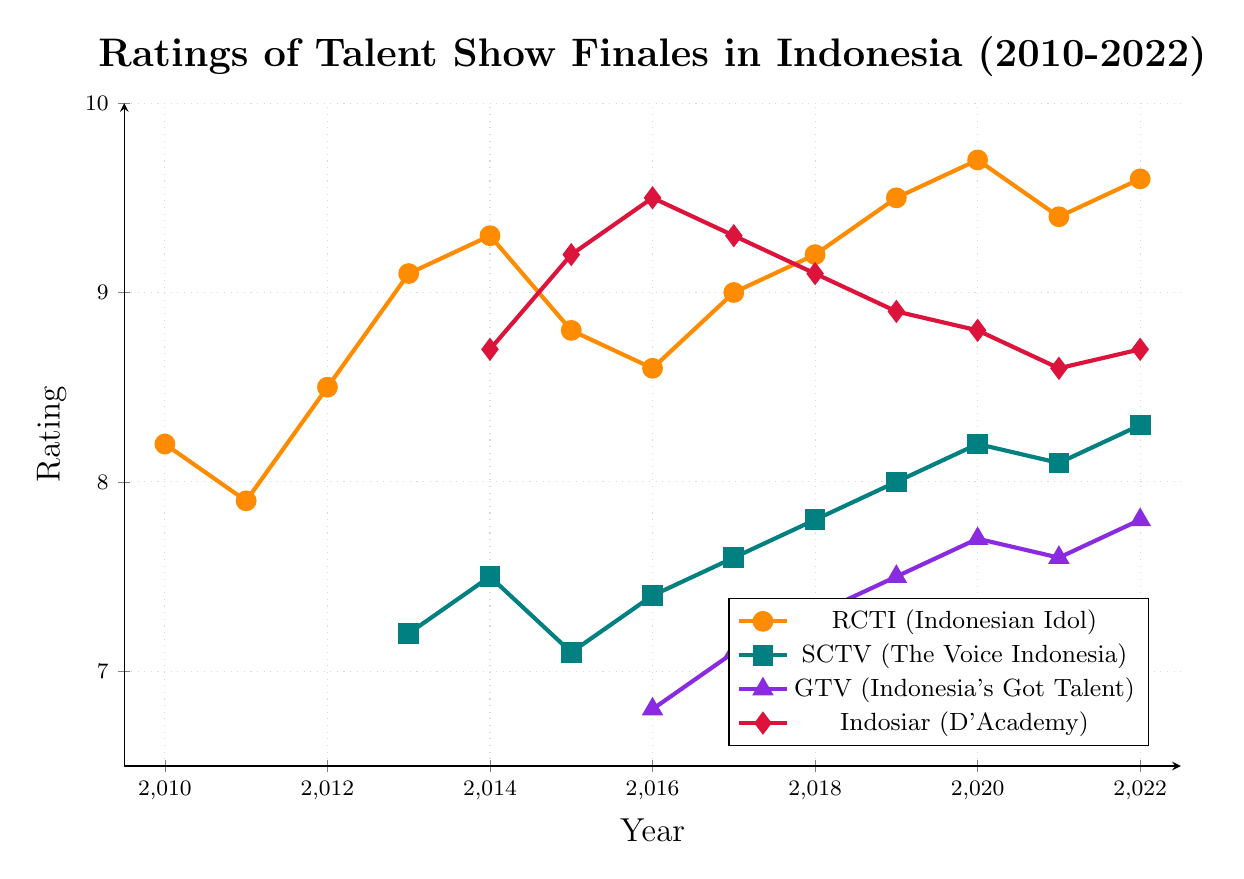What's the trend of RCTI (Indonesian Idol) ratings from 2013 to 2022? From the figure, observe the line representing RCTI (Indonesian Idol) from 2013 to 2022. The ratings start at 9.1 in 2013 and exhibit slight fluctuations, peaking at 9.7 in 2020 and ending at 9.6 in 2022.
Answer: Increasing with slight fluctuations Which network had the highest rating in 2016? Check the 2016 data points: RCTI (Indonesian Idol) has an 8.6 rating, SCTV (The Voice Indonesia) has a 7.4 rating, GTV (Indonesia's Got Talent) has a 6.8 rating, and Indosiar (D'Academy) has a 9.5 rating.
Answer: Indosiar (D'Academy) What is the average rating of SCTV (The Voice Indonesia) from 2013 to 2022? Sum the ratings from 2013 to 2022 and divide by the number of years: (7.2 + 7.5 + 7.1 + 7.4 + 7.6 + 7.8 + 8.0 + 8.2 + 8.1 + 8.3) / 10 = 7.72.
Answer: 7.72 How do the trend lines of GTV (Indonesia's Got Talent) and Indosiar (D'Academy) compare from 2016 to 2022? Observe the trends: GTV starts at 6.8 in 2016 and gradually rises to 7.8 in 2022, while Indosiar starts at a peak of 9.5 in 2016, then slightly declines to 8.7 in 2022.
Answer: GTV increases, Indosiar decreases In which year did RCTI (Indonesian Idol) achieve its lowest rating? Check the RCTI (Indonesian Idol) line for the lowest point. The lowest rating is 7.9 in 2011.
Answer: 2011 